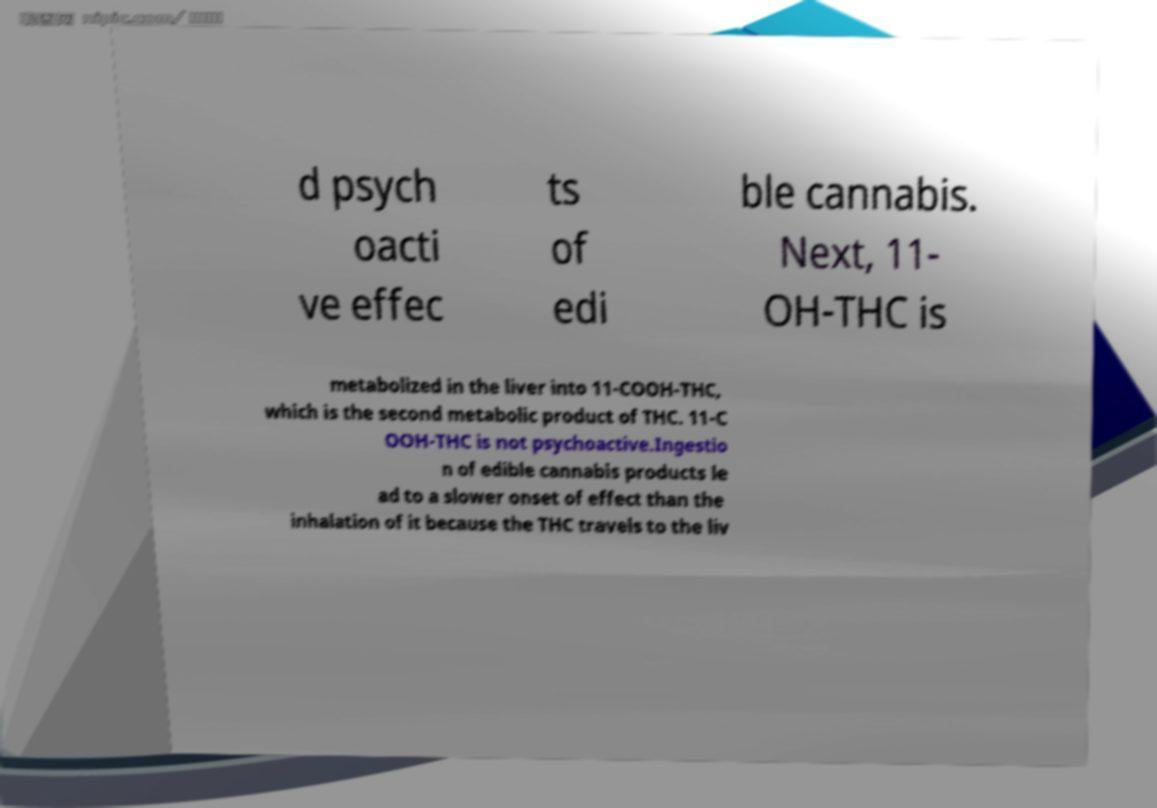Please identify and transcribe the text found in this image. d psych oacti ve effec ts of edi ble cannabis. Next, 11- OH-THC is metabolized in the liver into 11-COOH-THC, which is the second metabolic product of THC. 11-C OOH-THC is not psychoactive.Ingestio n of edible cannabis products le ad to a slower onset of effect than the inhalation of it because the THC travels to the liv 